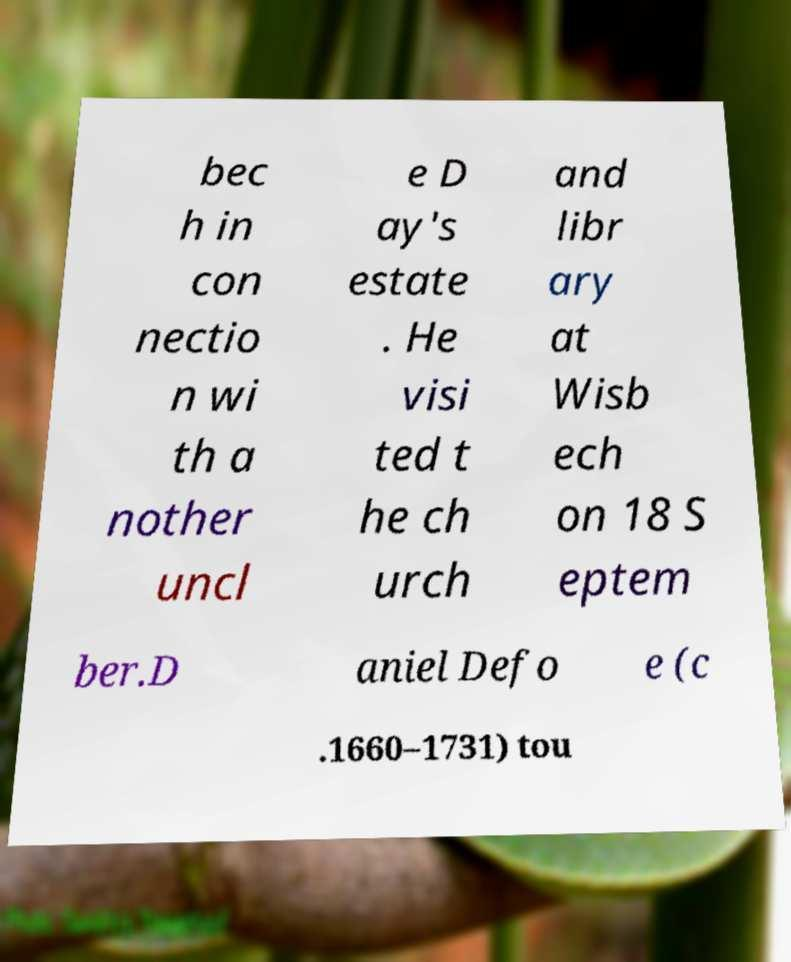I need the written content from this picture converted into text. Can you do that? bec h in con nectio n wi th a nother uncl e D ay's estate . He visi ted t he ch urch and libr ary at Wisb ech on 18 S eptem ber.D aniel Defo e (c .1660–1731) tou 